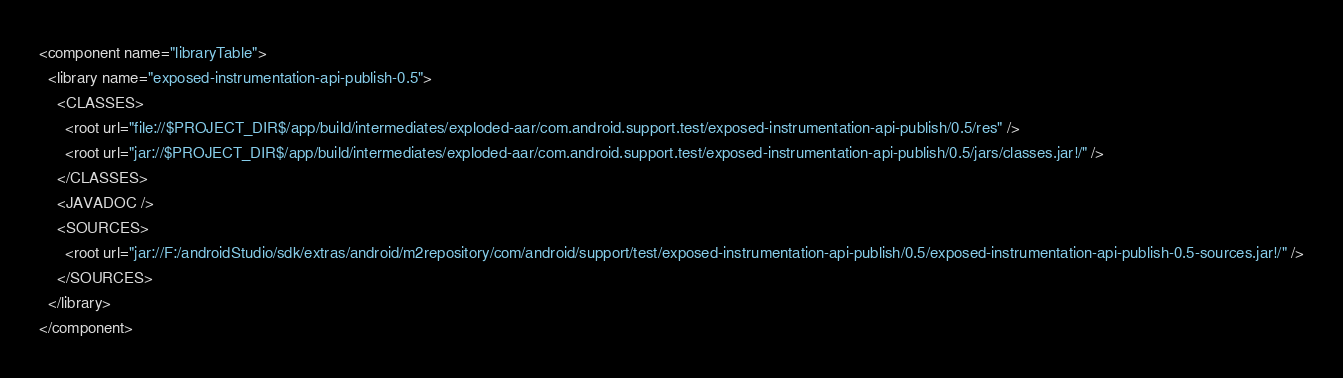<code> <loc_0><loc_0><loc_500><loc_500><_XML_><component name="libraryTable">
  <library name="exposed-instrumentation-api-publish-0.5">
    <CLASSES>
      <root url="file://$PROJECT_DIR$/app/build/intermediates/exploded-aar/com.android.support.test/exposed-instrumentation-api-publish/0.5/res" />
      <root url="jar://$PROJECT_DIR$/app/build/intermediates/exploded-aar/com.android.support.test/exposed-instrumentation-api-publish/0.5/jars/classes.jar!/" />
    </CLASSES>
    <JAVADOC />
    <SOURCES>
      <root url="jar://F:/androidStudio/sdk/extras/android/m2repository/com/android/support/test/exposed-instrumentation-api-publish/0.5/exposed-instrumentation-api-publish-0.5-sources.jar!/" />
    </SOURCES>
  </library>
</component></code> 